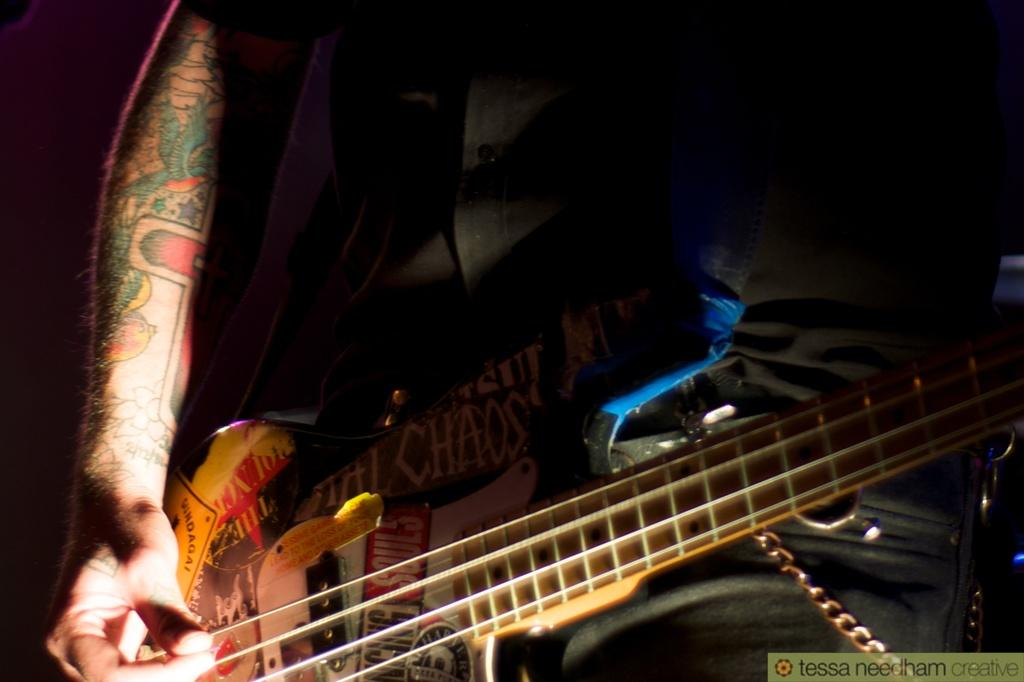What is the main subject of the image? There is a man in the image. What is the man holding in the image? The man is holding a guitar. What type of mint is growing in the man's guitar in the image? There is no mint or any plant growing in the guitar in the image. 